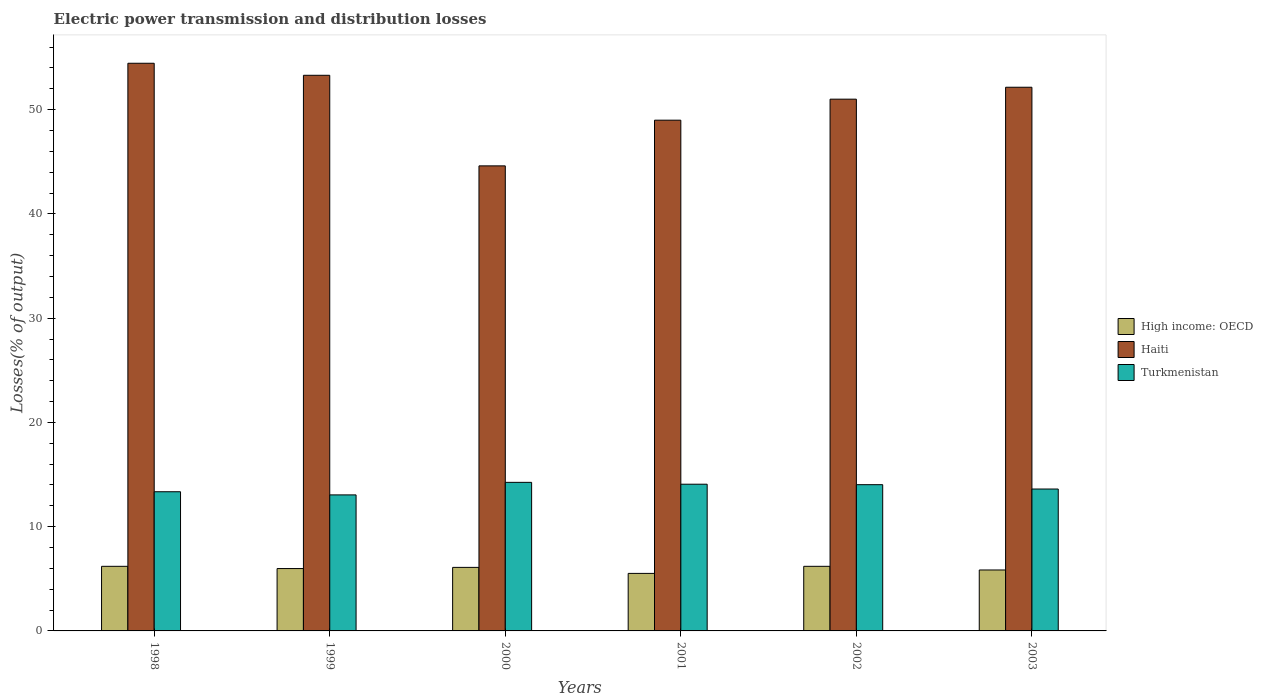How many groups of bars are there?
Provide a short and direct response. 6. Are the number of bars per tick equal to the number of legend labels?
Ensure brevity in your answer.  Yes. Are the number of bars on each tick of the X-axis equal?
Provide a succinct answer. Yes. How many bars are there on the 1st tick from the left?
Your response must be concise. 3. What is the label of the 5th group of bars from the left?
Offer a very short reply. 2002. What is the electric power transmission and distribution losses in Haiti in 1998?
Ensure brevity in your answer.  54.45. Across all years, what is the maximum electric power transmission and distribution losses in High income: OECD?
Provide a succinct answer. 6.2. Across all years, what is the minimum electric power transmission and distribution losses in High income: OECD?
Make the answer very short. 5.52. In which year was the electric power transmission and distribution losses in High income: OECD maximum?
Offer a very short reply. 1998. What is the total electric power transmission and distribution losses in Turkmenistan in the graph?
Give a very brief answer. 82.36. What is the difference between the electric power transmission and distribution losses in High income: OECD in 1999 and that in 2000?
Your response must be concise. -0.11. What is the difference between the electric power transmission and distribution losses in High income: OECD in 2000 and the electric power transmission and distribution losses in Haiti in 1999?
Offer a very short reply. -47.2. What is the average electric power transmission and distribution losses in Haiti per year?
Offer a terse response. 50.75. In the year 1998, what is the difference between the electric power transmission and distribution losses in Turkmenistan and electric power transmission and distribution losses in Haiti?
Your response must be concise. -41.1. In how many years, is the electric power transmission and distribution losses in Turkmenistan greater than 40 %?
Your answer should be very brief. 0. What is the ratio of the electric power transmission and distribution losses in Haiti in 1998 to that in 2001?
Keep it short and to the point. 1.11. Is the electric power transmission and distribution losses in High income: OECD in 1998 less than that in 2002?
Ensure brevity in your answer.  No. Is the difference between the electric power transmission and distribution losses in Turkmenistan in 2000 and 2002 greater than the difference between the electric power transmission and distribution losses in Haiti in 2000 and 2002?
Your answer should be very brief. Yes. What is the difference between the highest and the second highest electric power transmission and distribution losses in High income: OECD?
Offer a very short reply. 0. What is the difference between the highest and the lowest electric power transmission and distribution losses in Haiti?
Keep it short and to the point. 9.84. In how many years, is the electric power transmission and distribution losses in High income: OECD greater than the average electric power transmission and distribution losses in High income: OECD taken over all years?
Give a very brief answer. 4. Is the sum of the electric power transmission and distribution losses in Turkmenistan in 1998 and 2001 greater than the maximum electric power transmission and distribution losses in Haiti across all years?
Your answer should be very brief. No. What does the 2nd bar from the left in 1999 represents?
Keep it short and to the point. Haiti. What does the 2nd bar from the right in 2001 represents?
Ensure brevity in your answer.  Haiti. Is it the case that in every year, the sum of the electric power transmission and distribution losses in High income: OECD and electric power transmission and distribution losses in Haiti is greater than the electric power transmission and distribution losses in Turkmenistan?
Offer a very short reply. Yes. What is the difference between two consecutive major ticks on the Y-axis?
Your answer should be very brief. 10. Does the graph contain any zero values?
Make the answer very short. No. Does the graph contain grids?
Ensure brevity in your answer.  No. Where does the legend appear in the graph?
Your answer should be compact. Center right. What is the title of the graph?
Provide a succinct answer. Electric power transmission and distribution losses. Does "Monaco" appear as one of the legend labels in the graph?
Provide a succinct answer. No. What is the label or title of the Y-axis?
Your answer should be compact. Losses(% of output). What is the Losses(% of output) in High income: OECD in 1998?
Make the answer very short. 6.2. What is the Losses(% of output) of Haiti in 1998?
Your answer should be compact. 54.45. What is the Losses(% of output) of Turkmenistan in 1998?
Provide a succinct answer. 13.35. What is the Losses(% of output) in High income: OECD in 1999?
Offer a terse response. 5.98. What is the Losses(% of output) in Haiti in 1999?
Offer a terse response. 53.3. What is the Losses(% of output) of Turkmenistan in 1999?
Make the answer very short. 13.05. What is the Losses(% of output) in High income: OECD in 2000?
Provide a short and direct response. 6.09. What is the Losses(% of output) of Haiti in 2000?
Ensure brevity in your answer.  44.61. What is the Losses(% of output) of Turkmenistan in 2000?
Give a very brief answer. 14.25. What is the Losses(% of output) in High income: OECD in 2001?
Your response must be concise. 5.52. What is the Losses(% of output) of Haiti in 2001?
Provide a succinct answer. 48.99. What is the Losses(% of output) in Turkmenistan in 2001?
Ensure brevity in your answer.  14.07. What is the Losses(% of output) in High income: OECD in 2002?
Your answer should be compact. 6.2. What is the Losses(% of output) of Haiti in 2002?
Your answer should be compact. 51.01. What is the Losses(% of output) of Turkmenistan in 2002?
Offer a terse response. 14.03. What is the Losses(% of output) in High income: OECD in 2003?
Provide a succinct answer. 5.85. What is the Losses(% of output) in Haiti in 2003?
Your response must be concise. 52.15. What is the Losses(% of output) of Turkmenistan in 2003?
Keep it short and to the point. 13.61. Across all years, what is the maximum Losses(% of output) of High income: OECD?
Your answer should be compact. 6.2. Across all years, what is the maximum Losses(% of output) of Haiti?
Give a very brief answer. 54.45. Across all years, what is the maximum Losses(% of output) of Turkmenistan?
Keep it short and to the point. 14.25. Across all years, what is the minimum Losses(% of output) in High income: OECD?
Provide a short and direct response. 5.52. Across all years, what is the minimum Losses(% of output) of Haiti?
Provide a short and direct response. 44.61. Across all years, what is the minimum Losses(% of output) in Turkmenistan?
Provide a succinct answer. 13.05. What is the total Losses(% of output) of High income: OECD in the graph?
Provide a short and direct response. 35.83. What is the total Losses(% of output) in Haiti in the graph?
Keep it short and to the point. 304.5. What is the total Losses(% of output) of Turkmenistan in the graph?
Provide a succinct answer. 82.36. What is the difference between the Losses(% of output) in High income: OECD in 1998 and that in 1999?
Your answer should be very brief. 0.21. What is the difference between the Losses(% of output) of Haiti in 1998 and that in 1999?
Your answer should be very brief. 1.15. What is the difference between the Losses(% of output) of Turkmenistan in 1998 and that in 1999?
Provide a short and direct response. 0.3. What is the difference between the Losses(% of output) in High income: OECD in 1998 and that in 2000?
Offer a terse response. 0.1. What is the difference between the Losses(% of output) in Haiti in 1998 and that in 2000?
Keep it short and to the point. 9.84. What is the difference between the Losses(% of output) in Turkmenistan in 1998 and that in 2000?
Make the answer very short. -0.9. What is the difference between the Losses(% of output) of High income: OECD in 1998 and that in 2001?
Offer a very short reply. 0.68. What is the difference between the Losses(% of output) of Haiti in 1998 and that in 2001?
Provide a succinct answer. 5.46. What is the difference between the Losses(% of output) of Turkmenistan in 1998 and that in 2001?
Make the answer very short. -0.72. What is the difference between the Losses(% of output) of High income: OECD in 1998 and that in 2002?
Make the answer very short. 0. What is the difference between the Losses(% of output) in Haiti in 1998 and that in 2002?
Your answer should be very brief. 3.44. What is the difference between the Losses(% of output) of Turkmenistan in 1998 and that in 2002?
Make the answer very short. -0.68. What is the difference between the Losses(% of output) of High income: OECD in 1998 and that in 2003?
Offer a very short reply. 0.35. What is the difference between the Losses(% of output) of Haiti in 1998 and that in 2003?
Your answer should be compact. 2.3. What is the difference between the Losses(% of output) in Turkmenistan in 1998 and that in 2003?
Offer a very short reply. -0.26. What is the difference between the Losses(% of output) in High income: OECD in 1999 and that in 2000?
Offer a very short reply. -0.11. What is the difference between the Losses(% of output) in Haiti in 1999 and that in 2000?
Provide a short and direct response. 8.69. What is the difference between the Losses(% of output) of Turkmenistan in 1999 and that in 2000?
Make the answer very short. -1.2. What is the difference between the Losses(% of output) of High income: OECD in 1999 and that in 2001?
Provide a succinct answer. 0.47. What is the difference between the Losses(% of output) in Haiti in 1999 and that in 2001?
Your answer should be very brief. 4.31. What is the difference between the Losses(% of output) in Turkmenistan in 1999 and that in 2001?
Your answer should be very brief. -1.02. What is the difference between the Losses(% of output) of High income: OECD in 1999 and that in 2002?
Ensure brevity in your answer.  -0.21. What is the difference between the Losses(% of output) in Haiti in 1999 and that in 2002?
Your answer should be very brief. 2.29. What is the difference between the Losses(% of output) of Turkmenistan in 1999 and that in 2002?
Offer a very short reply. -0.98. What is the difference between the Losses(% of output) of High income: OECD in 1999 and that in 2003?
Provide a short and direct response. 0.14. What is the difference between the Losses(% of output) in Haiti in 1999 and that in 2003?
Provide a short and direct response. 1.15. What is the difference between the Losses(% of output) in Turkmenistan in 1999 and that in 2003?
Offer a very short reply. -0.56. What is the difference between the Losses(% of output) of High income: OECD in 2000 and that in 2001?
Keep it short and to the point. 0.58. What is the difference between the Losses(% of output) of Haiti in 2000 and that in 2001?
Your response must be concise. -4.38. What is the difference between the Losses(% of output) of Turkmenistan in 2000 and that in 2001?
Your answer should be very brief. 0.18. What is the difference between the Losses(% of output) of High income: OECD in 2000 and that in 2002?
Ensure brevity in your answer.  -0.1. What is the difference between the Losses(% of output) in Haiti in 2000 and that in 2002?
Offer a terse response. -6.4. What is the difference between the Losses(% of output) of Turkmenistan in 2000 and that in 2002?
Provide a succinct answer. 0.22. What is the difference between the Losses(% of output) of High income: OECD in 2000 and that in 2003?
Give a very brief answer. 0.25. What is the difference between the Losses(% of output) of Haiti in 2000 and that in 2003?
Provide a succinct answer. -7.54. What is the difference between the Losses(% of output) in Turkmenistan in 2000 and that in 2003?
Ensure brevity in your answer.  0.64. What is the difference between the Losses(% of output) of High income: OECD in 2001 and that in 2002?
Give a very brief answer. -0.68. What is the difference between the Losses(% of output) in Haiti in 2001 and that in 2002?
Make the answer very short. -2.02. What is the difference between the Losses(% of output) of Turkmenistan in 2001 and that in 2002?
Your answer should be compact. 0.04. What is the difference between the Losses(% of output) in High income: OECD in 2001 and that in 2003?
Make the answer very short. -0.33. What is the difference between the Losses(% of output) of Haiti in 2001 and that in 2003?
Keep it short and to the point. -3.16. What is the difference between the Losses(% of output) of Turkmenistan in 2001 and that in 2003?
Offer a terse response. 0.46. What is the difference between the Losses(% of output) in High income: OECD in 2002 and that in 2003?
Your answer should be very brief. 0.35. What is the difference between the Losses(% of output) of Haiti in 2002 and that in 2003?
Your answer should be compact. -1.14. What is the difference between the Losses(% of output) of Turkmenistan in 2002 and that in 2003?
Give a very brief answer. 0.42. What is the difference between the Losses(% of output) in High income: OECD in 1998 and the Losses(% of output) in Haiti in 1999?
Your answer should be compact. -47.1. What is the difference between the Losses(% of output) in High income: OECD in 1998 and the Losses(% of output) in Turkmenistan in 1999?
Provide a succinct answer. -6.85. What is the difference between the Losses(% of output) of Haiti in 1998 and the Losses(% of output) of Turkmenistan in 1999?
Your answer should be compact. 41.4. What is the difference between the Losses(% of output) in High income: OECD in 1998 and the Losses(% of output) in Haiti in 2000?
Ensure brevity in your answer.  -38.41. What is the difference between the Losses(% of output) in High income: OECD in 1998 and the Losses(% of output) in Turkmenistan in 2000?
Ensure brevity in your answer.  -8.05. What is the difference between the Losses(% of output) of Haiti in 1998 and the Losses(% of output) of Turkmenistan in 2000?
Make the answer very short. 40.2. What is the difference between the Losses(% of output) of High income: OECD in 1998 and the Losses(% of output) of Haiti in 2001?
Provide a short and direct response. -42.79. What is the difference between the Losses(% of output) in High income: OECD in 1998 and the Losses(% of output) in Turkmenistan in 2001?
Offer a terse response. -7.87. What is the difference between the Losses(% of output) in Haiti in 1998 and the Losses(% of output) in Turkmenistan in 2001?
Offer a very short reply. 40.38. What is the difference between the Losses(% of output) in High income: OECD in 1998 and the Losses(% of output) in Haiti in 2002?
Keep it short and to the point. -44.81. What is the difference between the Losses(% of output) in High income: OECD in 1998 and the Losses(% of output) in Turkmenistan in 2002?
Provide a succinct answer. -7.83. What is the difference between the Losses(% of output) of Haiti in 1998 and the Losses(% of output) of Turkmenistan in 2002?
Offer a very short reply. 40.42. What is the difference between the Losses(% of output) in High income: OECD in 1998 and the Losses(% of output) in Haiti in 2003?
Make the answer very short. -45.95. What is the difference between the Losses(% of output) in High income: OECD in 1998 and the Losses(% of output) in Turkmenistan in 2003?
Your answer should be very brief. -7.41. What is the difference between the Losses(% of output) of Haiti in 1998 and the Losses(% of output) of Turkmenistan in 2003?
Make the answer very short. 40.84. What is the difference between the Losses(% of output) of High income: OECD in 1999 and the Losses(% of output) of Haiti in 2000?
Ensure brevity in your answer.  -38.62. What is the difference between the Losses(% of output) in High income: OECD in 1999 and the Losses(% of output) in Turkmenistan in 2000?
Provide a short and direct response. -8.27. What is the difference between the Losses(% of output) in Haiti in 1999 and the Losses(% of output) in Turkmenistan in 2000?
Ensure brevity in your answer.  39.04. What is the difference between the Losses(% of output) in High income: OECD in 1999 and the Losses(% of output) in Haiti in 2001?
Provide a short and direct response. -43.01. What is the difference between the Losses(% of output) of High income: OECD in 1999 and the Losses(% of output) of Turkmenistan in 2001?
Your answer should be compact. -8.09. What is the difference between the Losses(% of output) of Haiti in 1999 and the Losses(% of output) of Turkmenistan in 2001?
Offer a very short reply. 39.22. What is the difference between the Losses(% of output) of High income: OECD in 1999 and the Losses(% of output) of Haiti in 2002?
Your response must be concise. -45.02. What is the difference between the Losses(% of output) of High income: OECD in 1999 and the Losses(% of output) of Turkmenistan in 2002?
Provide a succinct answer. -8.05. What is the difference between the Losses(% of output) in Haiti in 1999 and the Losses(% of output) in Turkmenistan in 2002?
Your answer should be very brief. 39.27. What is the difference between the Losses(% of output) of High income: OECD in 1999 and the Losses(% of output) of Haiti in 2003?
Offer a terse response. -46.17. What is the difference between the Losses(% of output) in High income: OECD in 1999 and the Losses(% of output) in Turkmenistan in 2003?
Offer a very short reply. -7.63. What is the difference between the Losses(% of output) in Haiti in 1999 and the Losses(% of output) in Turkmenistan in 2003?
Provide a succinct answer. 39.68. What is the difference between the Losses(% of output) of High income: OECD in 2000 and the Losses(% of output) of Haiti in 2001?
Your answer should be compact. -42.9. What is the difference between the Losses(% of output) of High income: OECD in 2000 and the Losses(% of output) of Turkmenistan in 2001?
Offer a terse response. -7.98. What is the difference between the Losses(% of output) of Haiti in 2000 and the Losses(% of output) of Turkmenistan in 2001?
Make the answer very short. 30.54. What is the difference between the Losses(% of output) of High income: OECD in 2000 and the Losses(% of output) of Haiti in 2002?
Offer a very short reply. -44.91. What is the difference between the Losses(% of output) in High income: OECD in 2000 and the Losses(% of output) in Turkmenistan in 2002?
Make the answer very short. -7.93. What is the difference between the Losses(% of output) of Haiti in 2000 and the Losses(% of output) of Turkmenistan in 2002?
Give a very brief answer. 30.58. What is the difference between the Losses(% of output) in High income: OECD in 2000 and the Losses(% of output) in Haiti in 2003?
Provide a short and direct response. -46.05. What is the difference between the Losses(% of output) of High income: OECD in 2000 and the Losses(% of output) of Turkmenistan in 2003?
Offer a terse response. -7.52. What is the difference between the Losses(% of output) in Haiti in 2000 and the Losses(% of output) in Turkmenistan in 2003?
Your response must be concise. 31. What is the difference between the Losses(% of output) of High income: OECD in 2001 and the Losses(% of output) of Haiti in 2002?
Provide a short and direct response. -45.49. What is the difference between the Losses(% of output) of High income: OECD in 2001 and the Losses(% of output) of Turkmenistan in 2002?
Make the answer very short. -8.51. What is the difference between the Losses(% of output) of Haiti in 2001 and the Losses(% of output) of Turkmenistan in 2002?
Your answer should be very brief. 34.96. What is the difference between the Losses(% of output) of High income: OECD in 2001 and the Losses(% of output) of Haiti in 2003?
Your response must be concise. -46.63. What is the difference between the Losses(% of output) of High income: OECD in 2001 and the Losses(% of output) of Turkmenistan in 2003?
Make the answer very short. -8.09. What is the difference between the Losses(% of output) of Haiti in 2001 and the Losses(% of output) of Turkmenistan in 2003?
Provide a short and direct response. 35.38. What is the difference between the Losses(% of output) in High income: OECD in 2002 and the Losses(% of output) in Haiti in 2003?
Provide a succinct answer. -45.95. What is the difference between the Losses(% of output) in High income: OECD in 2002 and the Losses(% of output) in Turkmenistan in 2003?
Provide a succinct answer. -7.41. What is the difference between the Losses(% of output) of Haiti in 2002 and the Losses(% of output) of Turkmenistan in 2003?
Make the answer very short. 37.39. What is the average Losses(% of output) in High income: OECD per year?
Your response must be concise. 5.97. What is the average Losses(% of output) of Haiti per year?
Make the answer very short. 50.75. What is the average Losses(% of output) in Turkmenistan per year?
Keep it short and to the point. 13.73. In the year 1998, what is the difference between the Losses(% of output) of High income: OECD and Losses(% of output) of Haiti?
Provide a succinct answer. -48.25. In the year 1998, what is the difference between the Losses(% of output) in High income: OECD and Losses(% of output) in Turkmenistan?
Provide a short and direct response. -7.15. In the year 1998, what is the difference between the Losses(% of output) in Haiti and Losses(% of output) in Turkmenistan?
Your answer should be very brief. 41.1. In the year 1999, what is the difference between the Losses(% of output) in High income: OECD and Losses(% of output) in Haiti?
Make the answer very short. -47.31. In the year 1999, what is the difference between the Losses(% of output) in High income: OECD and Losses(% of output) in Turkmenistan?
Make the answer very short. -7.06. In the year 1999, what is the difference between the Losses(% of output) of Haiti and Losses(% of output) of Turkmenistan?
Give a very brief answer. 40.25. In the year 2000, what is the difference between the Losses(% of output) in High income: OECD and Losses(% of output) in Haiti?
Your answer should be compact. -38.51. In the year 2000, what is the difference between the Losses(% of output) in High income: OECD and Losses(% of output) in Turkmenistan?
Offer a very short reply. -8.16. In the year 2000, what is the difference between the Losses(% of output) in Haiti and Losses(% of output) in Turkmenistan?
Offer a very short reply. 30.36. In the year 2001, what is the difference between the Losses(% of output) in High income: OECD and Losses(% of output) in Haiti?
Offer a terse response. -43.47. In the year 2001, what is the difference between the Losses(% of output) of High income: OECD and Losses(% of output) of Turkmenistan?
Keep it short and to the point. -8.55. In the year 2001, what is the difference between the Losses(% of output) in Haiti and Losses(% of output) in Turkmenistan?
Provide a succinct answer. 34.92. In the year 2002, what is the difference between the Losses(% of output) in High income: OECD and Losses(% of output) in Haiti?
Your response must be concise. -44.81. In the year 2002, what is the difference between the Losses(% of output) of High income: OECD and Losses(% of output) of Turkmenistan?
Ensure brevity in your answer.  -7.83. In the year 2002, what is the difference between the Losses(% of output) of Haiti and Losses(% of output) of Turkmenistan?
Your answer should be very brief. 36.98. In the year 2003, what is the difference between the Losses(% of output) in High income: OECD and Losses(% of output) in Haiti?
Your answer should be very brief. -46.3. In the year 2003, what is the difference between the Losses(% of output) of High income: OECD and Losses(% of output) of Turkmenistan?
Provide a succinct answer. -7.77. In the year 2003, what is the difference between the Losses(% of output) in Haiti and Losses(% of output) in Turkmenistan?
Give a very brief answer. 38.54. What is the ratio of the Losses(% of output) of High income: OECD in 1998 to that in 1999?
Ensure brevity in your answer.  1.04. What is the ratio of the Losses(% of output) of Haiti in 1998 to that in 1999?
Your answer should be compact. 1.02. What is the ratio of the Losses(% of output) of Turkmenistan in 1998 to that in 1999?
Your answer should be compact. 1.02. What is the ratio of the Losses(% of output) in High income: OECD in 1998 to that in 2000?
Provide a short and direct response. 1.02. What is the ratio of the Losses(% of output) of Haiti in 1998 to that in 2000?
Provide a succinct answer. 1.22. What is the ratio of the Losses(% of output) of Turkmenistan in 1998 to that in 2000?
Your answer should be compact. 0.94. What is the ratio of the Losses(% of output) of High income: OECD in 1998 to that in 2001?
Offer a very short reply. 1.12. What is the ratio of the Losses(% of output) in Haiti in 1998 to that in 2001?
Your response must be concise. 1.11. What is the ratio of the Losses(% of output) in Turkmenistan in 1998 to that in 2001?
Your response must be concise. 0.95. What is the ratio of the Losses(% of output) of Haiti in 1998 to that in 2002?
Your response must be concise. 1.07. What is the ratio of the Losses(% of output) in Turkmenistan in 1998 to that in 2002?
Your answer should be very brief. 0.95. What is the ratio of the Losses(% of output) in High income: OECD in 1998 to that in 2003?
Ensure brevity in your answer.  1.06. What is the ratio of the Losses(% of output) of Haiti in 1998 to that in 2003?
Offer a very short reply. 1.04. What is the ratio of the Losses(% of output) of Turkmenistan in 1998 to that in 2003?
Your answer should be very brief. 0.98. What is the ratio of the Losses(% of output) in High income: OECD in 1999 to that in 2000?
Offer a very short reply. 0.98. What is the ratio of the Losses(% of output) in Haiti in 1999 to that in 2000?
Give a very brief answer. 1.19. What is the ratio of the Losses(% of output) in Turkmenistan in 1999 to that in 2000?
Your response must be concise. 0.92. What is the ratio of the Losses(% of output) in High income: OECD in 1999 to that in 2001?
Your response must be concise. 1.08. What is the ratio of the Losses(% of output) of Haiti in 1999 to that in 2001?
Ensure brevity in your answer.  1.09. What is the ratio of the Losses(% of output) in Turkmenistan in 1999 to that in 2001?
Ensure brevity in your answer.  0.93. What is the ratio of the Losses(% of output) in High income: OECD in 1999 to that in 2002?
Keep it short and to the point. 0.97. What is the ratio of the Losses(% of output) of Haiti in 1999 to that in 2002?
Give a very brief answer. 1.04. What is the ratio of the Losses(% of output) in Turkmenistan in 1999 to that in 2002?
Offer a terse response. 0.93. What is the ratio of the Losses(% of output) of High income: OECD in 1999 to that in 2003?
Offer a very short reply. 1.02. What is the ratio of the Losses(% of output) of Turkmenistan in 1999 to that in 2003?
Your answer should be very brief. 0.96. What is the ratio of the Losses(% of output) in High income: OECD in 2000 to that in 2001?
Provide a short and direct response. 1.1. What is the ratio of the Losses(% of output) of Haiti in 2000 to that in 2001?
Ensure brevity in your answer.  0.91. What is the ratio of the Losses(% of output) of Turkmenistan in 2000 to that in 2001?
Make the answer very short. 1.01. What is the ratio of the Losses(% of output) in High income: OECD in 2000 to that in 2002?
Give a very brief answer. 0.98. What is the ratio of the Losses(% of output) in Haiti in 2000 to that in 2002?
Give a very brief answer. 0.87. What is the ratio of the Losses(% of output) in Turkmenistan in 2000 to that in 2002?
Ensure brevity in your answer.  1.02. What is the ratio of the Losses(% of output) in High income: OECD in 2000 to that in 2003?
Ensure brevity in your answer.  1.04. What is the ratio of the Losses(% of output) of Haiti in 2000 to that in 2003?
Give a very brief answer. 0.86. What is the ratio of the Losses(% of output) of Turkmenistan in 2000 to that in 2003?
Offer a very short reply. 1.05. What is the ratio of the Losses(% of output) of High income: OECD in 2001 to that in 2002?
Keep it short and to the point. 0.89. What is the ratio of the Losses(% of output) in Haiti in 2001 to that in 2002?
Keep it short and to the point. 0.96. What is the ratio of the Losses(% of output) of Turkmenistan in 2001 to that in 2002?
Provide a short and direct response. 1. What is the ratio of the Losses(% of output) in High income: OECD in 2001 to that in 2003?
Make the answer very short. 0.94. What is the ratio of the Losses(% of output) of Haiti in 2001 to that in 2003?
Ensure brevity in your answer.  0.94. What is the ratio of the Losses(% of output) of Turkmenistan in 2001 to that in 2003?
Provide a succinct answer. 1.03. What is the ratio of the Losses(% of output) in High income: OECD in 2002 to that in 2003?
Provide a short and direct response. 1.06. What is the ratio of the Losses(% of output) in Haiti in 2002 to that in 2003?
Ensure brevity in your answer.  0.98. What is the ratio of the Losses(% of output) in Turkmenistan in 2002 to that in 2003?
Make the answer very short. 1.03. What is the difference between the highest and the second highest Losses(% of output) of High income: OECD?
Ensure brevity in your answer.  0. What is the difference between the highest and the second highest Losses(% of output) of Haiti?
Offer a very short reply. 1.15. What is the difference between the highest and the second highest Losses(% of output) of Turkmenistan?
Keep it short and to the point. 0.18. What is the difference between the highest and the lowest Losses(% of output) of High income: OECD?
Offer a very short reply. 0.68. What is the difference between the highest and the lowest Losses(% of output) of Haiti?
Your answer should be very brief. 9.84. What is the difference between the highest and the lowest Losses(% of output) in Turkmenistan?
Your response must be concise. 1.2. 